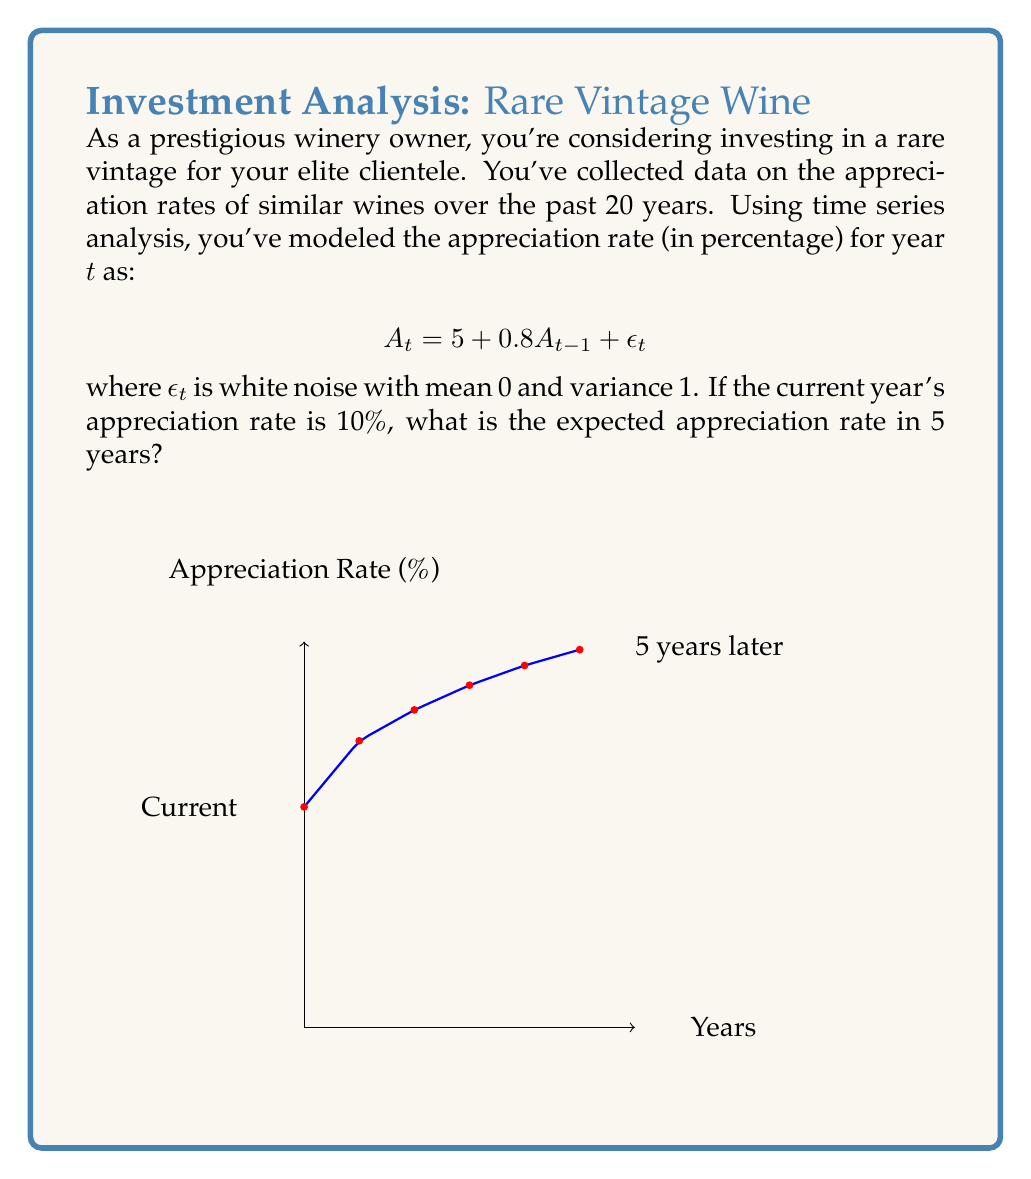Give your solution to this math problem. To solve this problem, we'll use the given time series model and iterate it for 5 years:

1) The model is: $A_t = 5 + 0.8A_{t-1} + \epsilon_t$

2) We're told that the current year's rate (let's call it $A_0$) is 10%.

3) To find the expected rate in 5 years, we need to calculate $E[A_5]$. We'll do this step by step:

   For $t = 1$: $E[A_1] = 5 + 0.8(10) + E[\epsilon_1] = 5 + 8 + 0 = 13$
   
   For $t = 2$: $E[A_2] = 5 + 0.8(13) + E[\epsilon_2] = 5 + 10.4 + 0 = 15.4$
   
   For $t = 3$: $E[A_3] = 5 + 0.8(15.4) + E[\epsilon_3] = 5 + 12.32 + 0 = 17.32$
   
   For $t = 4$: $E[A_4] = 5 + 0.8(17.32) + E[\epsilon_4] = 5 + 13.856 + 0 = 18.856$
   
   For $t = 5$: $E[A_5] = 5 + 0.8(18.856) + E[\epsilon_5] = 5 + 15.0848 + 0 = 20.0848$

4) Therefore, the expected appreciation rate in 5 years is approximately 20.08%.

Note: We use $E[\epsilon_t] = 0$ for all $t$ because $\epsilon_t$ is white noise with mean 0.
Answer: 20.08% 